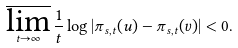<formula> <loc_0><loc_0><loc_500><loc_500>\varlimsup _ { t \to \infty } \frac { 1 } { t } \log \left | \pi _ { s , t } ( u ) - \pi _ { s , t } ( v ) \right | < 0 .</formula> 